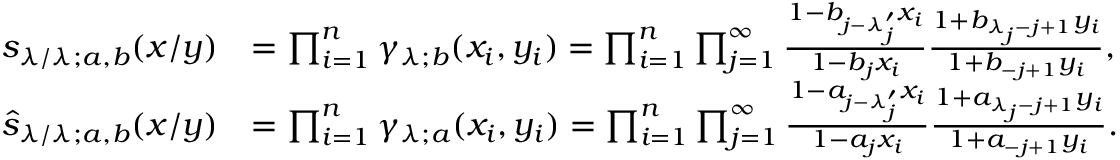<formula> <loc_0><loc_0><loc_500><loc_500>\begin{array} { r l } { s _ { \lambda / \lambda ; a , b } ( x / y ) } & { = \prod _ { i = 1 } ^ { n } \gamma _ { \lambda ; b } ( x _ { i } , y _ { i } ) = \prod _ { i = 1 } ^ { n } \prod _ { j = 1 } ^ { \infty } \frac { 1 - b _ { j - \lambda _ { j } ^ { \prime } } x _ { i } } { 1 - b _ { j } x _ { i } } \frac { 1 + b _ { \lambda _ { j } - j + 1 } y _ { i } } { 1 + b _ { - j + 1 } y _ { i } } , } \\ { \widehat { s } _ { \lambda / \lambda ; a , b } ( x / y ) } & { = \prod _ { i = 1 } ^ { n } \gamma _ { \lambda ; a } ( x _ { i } , y _ { i } ) = \prod _ { i = 1 } ^ { n } \prod _ { j = 1 } ^ { \infty } \frac { 1 - a _ { j - \lambda _ { j } ^ { \prime } } x _ { i } } { 1 - a _ { j } x _ { i } } \frac { 1 + a _ { \lambda _ { j } - j + 1 } y _ { i } } { 1 + a _ { - j + 1 } y _ { i } } . } \end{array}</formula> 